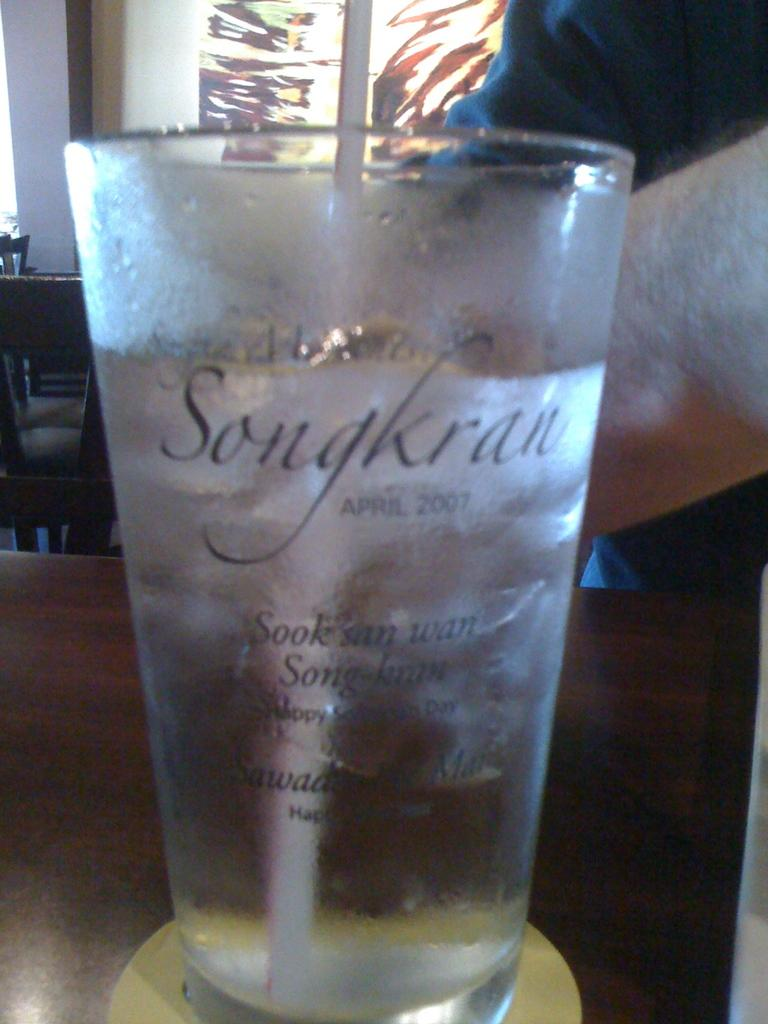<image>
Create a compact narrative representing the image presented. A cold frosted glass is labeled with the name Songkran. 